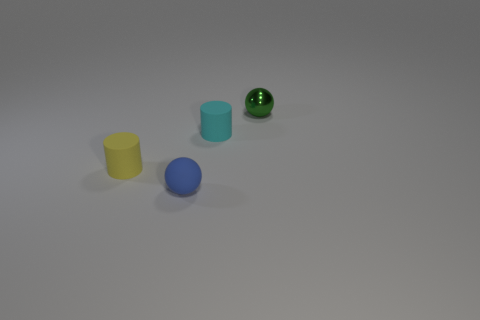Which objects appear to have a texture? The green speckled sphere on the far right has a visible texture, which gives it a distinct appearance compared to the smooth surfaces of the other objects. 